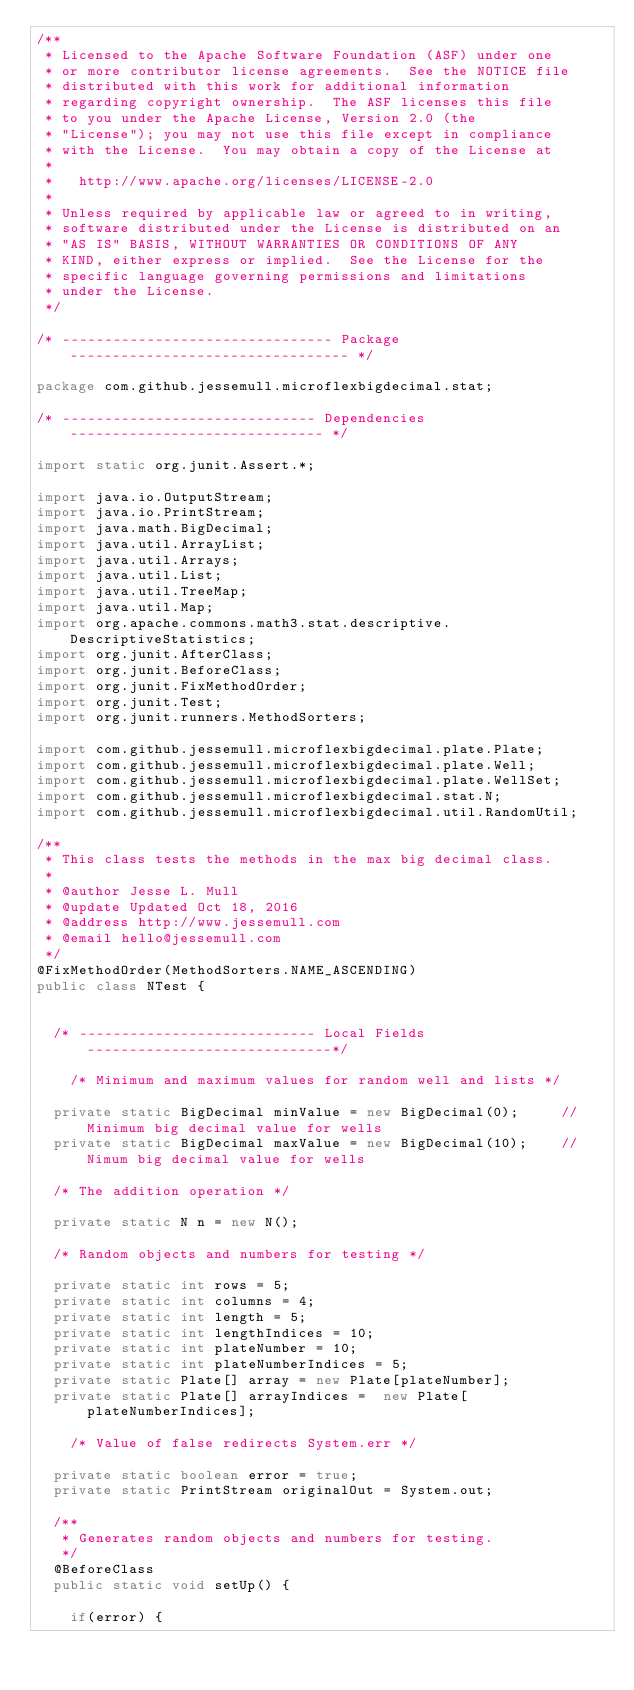<code> <loc_0><loc_0><loc_500><loc_500><_Java_>/**
 * Licensed to the Apache Software Foundation (ASF) under one
 * or more contributor license agreements.  See the NOTICE file
 * distributed with this work for additional information
 * regarding copyright ownership.  The ASF licenses this file
 * to you under the Apache License, Version 2.0 (the
 * "License"); you may not use this file except in compliance
 * with the License.  You may obtain a copy of the License at
 *
 *   http://www.apache.org/licenses/LICENSE-2.0
 *
 * Unless required by applicable law or agreed to in writing,
 * software distributed under the License is distributed on an
 * "AS IS" BASIS, WITHOUT WARRANTIES OR CONDITIONS OF ANY
 * KIND, either express or implied.  See the License for the
 * specific language governing permissions and limitations
 * under the License.
 */

/* -------------------------------- Package --------------------------------- */

package com.github.jessemull.microflexbigdecimal.stat;

/* ------------------------------ Dependencies ------------------------------ */

import static org.junit.Assert.*;

import java.io.OutputStream;
import java.io.PrintStream;
import java.math.BigDecimal;
import java.util.ArrayList;
import java.util.Arrays;
import java.util.List;
import java.util.TreeMap;
import java.util.Map;
import org.apache.commons.math3.stat.descriptive.DescriptiveStatistics;
import org.junit.AfterClass;
import org.junit.BeforeClass;
import org.junit.FixMethodOrder;
import org.junit.Test;
import org.junit.runners.MethodSorters;

import com.github.jessemull.microflexbigdecimal.plate.Plate;
import com.github.jessemull.microflexbigdecimal.plate.Well;
import com.github.jessemull.microflexbigdecimal.plate.WellSet;
import com.github.jessemull.microflexbigdecimal.stat.N;
import com.github.jessemull.microflexbigdecimal.util.RandomUtil;

/**
 * This class tests the methods in the max big decimal class.
 * 
 * @author Jesse L. Mull
 * @update Updated Oct 18, 2016
 * @address http://www.jessemull.com
 * @email hello@jessemull.com
 */
@FixMethodOrder(MethodSorters.NAME_ASCENDING)
public class NTest {


	/* ---------------------------- Local Fields -----------------------------*/
	
    /* Minimum and maximum values for random well and lists */
	
	private static BigDecimal minValue = new BigDecimal(0);     // Minimum big decimal value for wells
	private static BigDecimal maxValue = new BigDecimal(10);    // Nimum big decimal value for wells
	
	/* The addition operation */
	
	private static N n = new N();

	/* Random objects and numbers for testing */

	private static int rows = 5;
	private static int columns = 4;
	private static int length = 5;
	private static int lengthIndices = 10;
	private static int plateNumber = 10;
	private static int plateNumberIndices = 5;
	private static Plate[] array = new Plate[plateNumber];
	private static Plate[] arrayIndices =  new Plate[plateNumberIndices];
	
    /* Value of false redirects System.err */
	
	private static boolean error = true;
	private static PrintStream originalOut = System.out;

	/**
	 * Generates random objects and numbers for testing.
	 */
	@BeforeClass
	public static void setUp() {
		
		if(error) {
</code> 